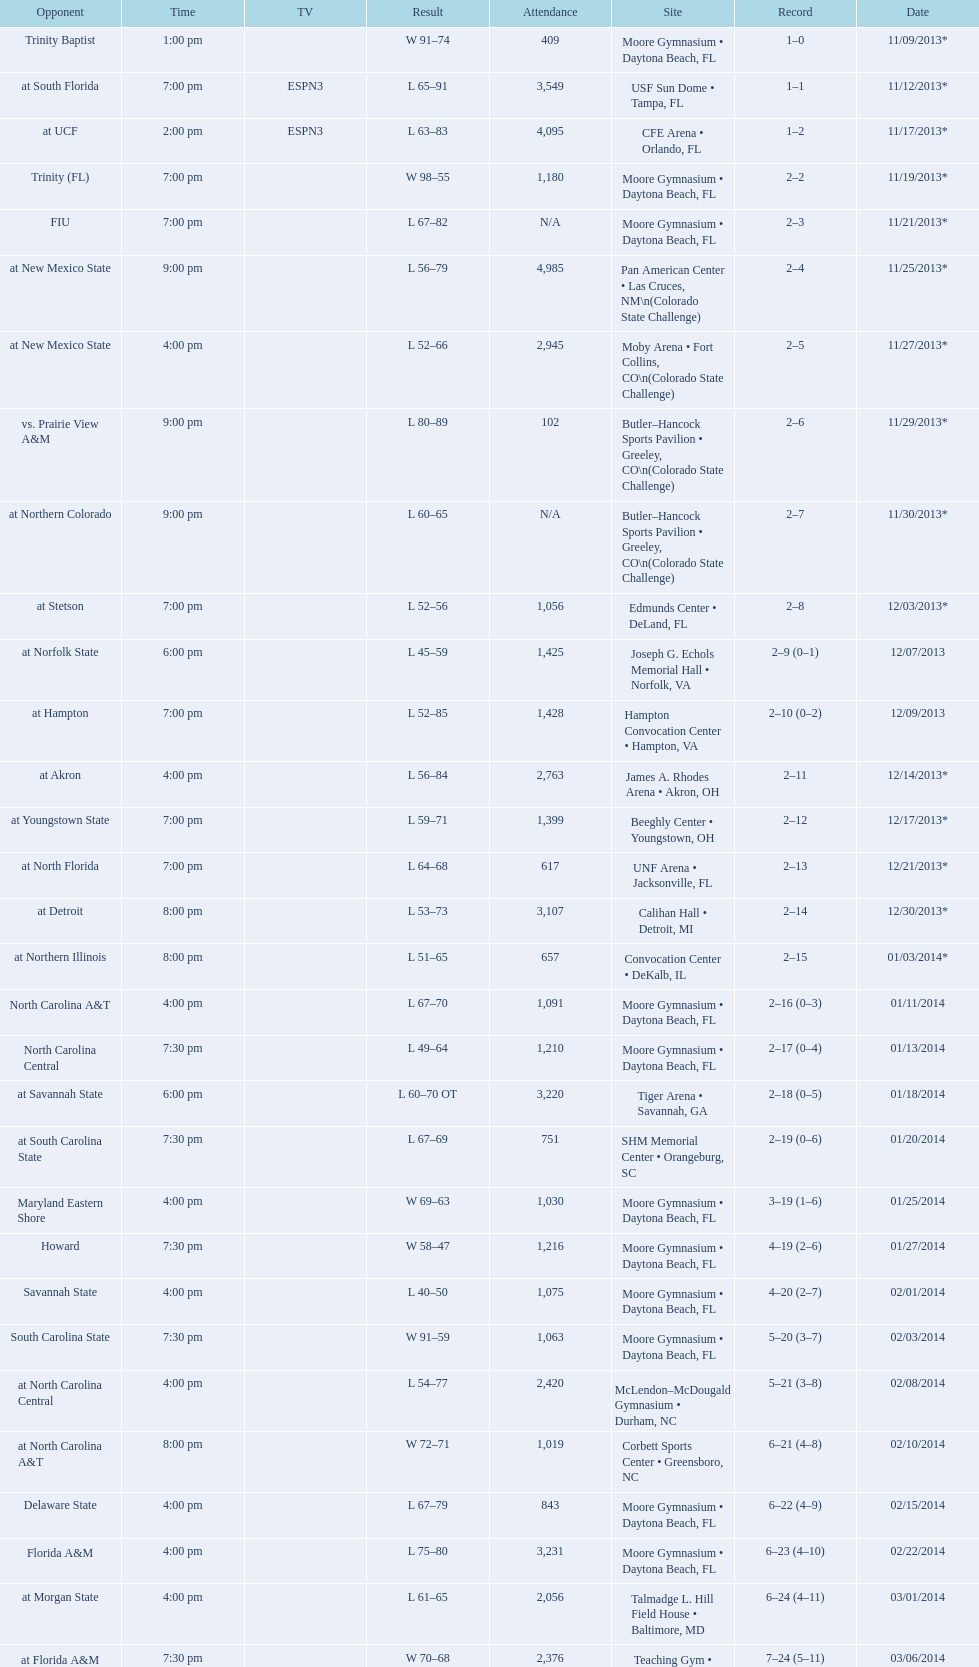Was the attendance of the game held on 11/19/2013 greater than 1,000? Yes. 